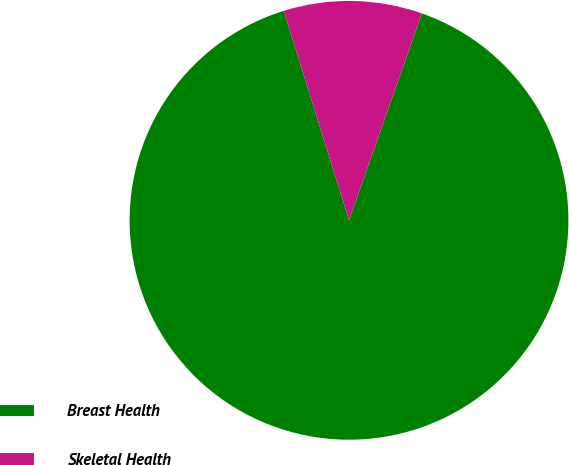Convert chart. <chart><loc_0><loc_0><loc_500><loc_500><pie_chart><fcel>Breast Health<fcel>Skeletal Health<nl><fcel>89.8%<fcel>10.2%<nl></chart> 